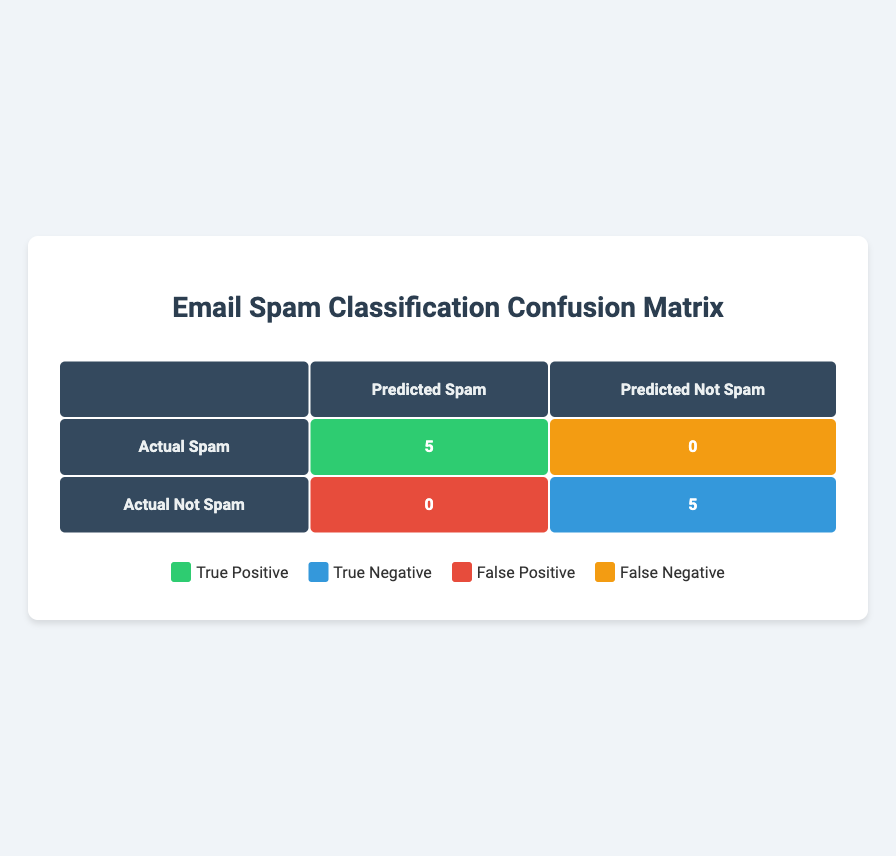What is the total number of true positives? The table indicates that there are 5 instances classified as true positives, as seen in the "Actual Spam" row under "Predicted Spam."
Answer: 5 What is the total number of false negatives? The table shows that the number of false negatives is 0, which is found in the "Actual Spam" row under "Predicted Not Spam."
Answer: 0 Are there any false positives in the classification? Looking at the "Actual Not Spam" row under "Predicted Spam," the count is 0, indicating that there were no false positives.
Answer: No What is the total number of instances classified as not spam? To find this, we sum the values in the "Predicted Not Spam" column: 0 (for Actual Spam) + 5 (for Actual Not Spam) = 5.
Answer: 5 What percentage of actual spam instances were correctly identified as spam? There are 5 actual spam instances, all of which were correctly predicted as spam, resulting in a percentage of (5/5) * 100 = 100%.
Answer: 100% What is the total number of emails classified in this confusion matrix? The total number of emails is the sum of all values in the confusion matrix: 5 (true positive) + 0 (false negative) + 0 (false positive) + 5 (true negative) = 10.
Answer: 10 Is the classification exact with no incorrect predictions? The table shows 0 false positives and 0 false negatives. Consequently, the classification is exact, meaning that there were no incorrect predictions.
Answer: Yes How many instances were predicted as spam? The total number of predicted spam instances can be calculated by adding the values in the "Predicted Spam" column: 5 (true positive) + 0 (false positive) = 5.
Answer: 5 What is the ratio of true negatives to false positives? There are 5 true negatives and 0 false positives, giving the ratio of true negatives to false positives as 5:0. However, since false positives are 0, this ratio is undefined in strict mathematical terms but would be stated as non-applicable.
Answer: Non-applicable 